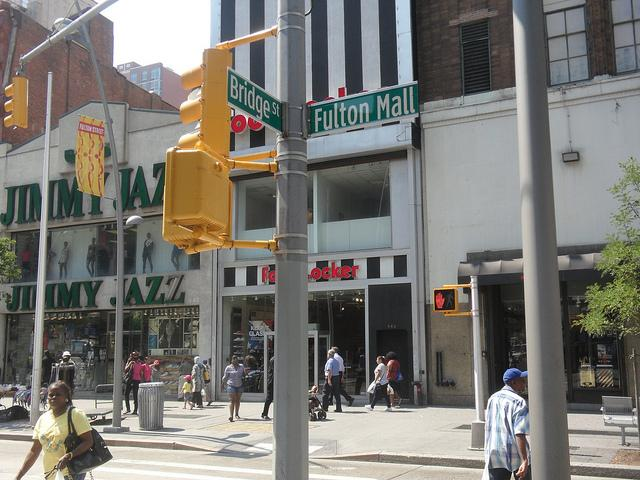Where should you go from the traffic light if you want to go to Fulton Mall? Please explain your reasoning. turn right. Fulton mall is to the right. 